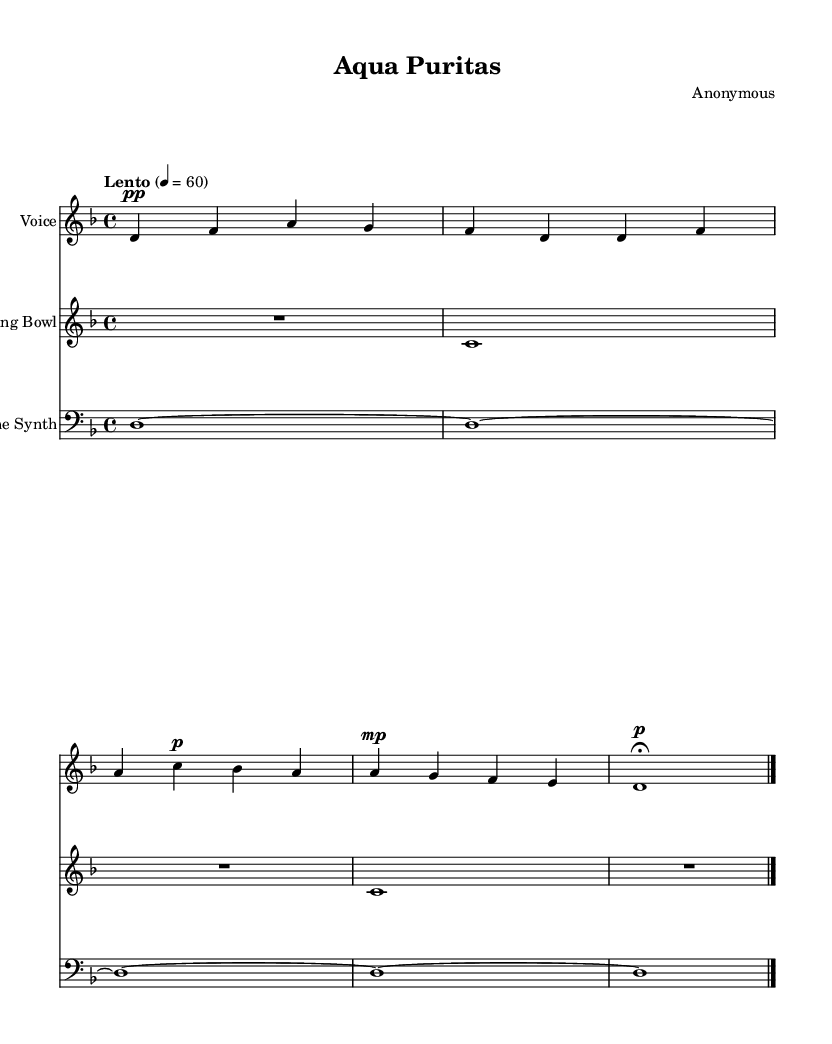What is the key signature of this music? The key signature is D minor, which typically features one flat (B flat). This can be deduced from the 'key d minor' notation in the music's global variable section.
Answer: D minor What is the time signature of this music? The time signature is 4/4, indicated by the 'time 4/4' notation under the global variable section. This means there are four beats per measure.
Answer: 4/4 What is the tempo marking of this piece? The tempo marking is "Lento," which means slow. This is stated clearly in the tempo section of the global variable.
Answer: Lento How many measures are in the vocal part? The vocal part consists of four measures as it spans from the first note to the last note of the voice section, indicated by the vertical lines in the notation.
Answer: 4 What is the first line of the lyrics? The first line of the lyrics reads "Aqua pura," which is visible in the text section beneath the vocal notes.
Answer: Aqua pura Which instrument plays a sustained note throughout the piece? The "Drone Synth" instrument plays a sustained note (D) throughout the piece, indicated by the repeated 'd1~' notation in its part.
Answer: Drone Synth What is the dynamic marking for the first vocal phrase? The dynamic marking for the first vocal phrase is pianissimo (pp), indicated by the 'pp' below the first note in the vocal part.
Answer: pianissimo 